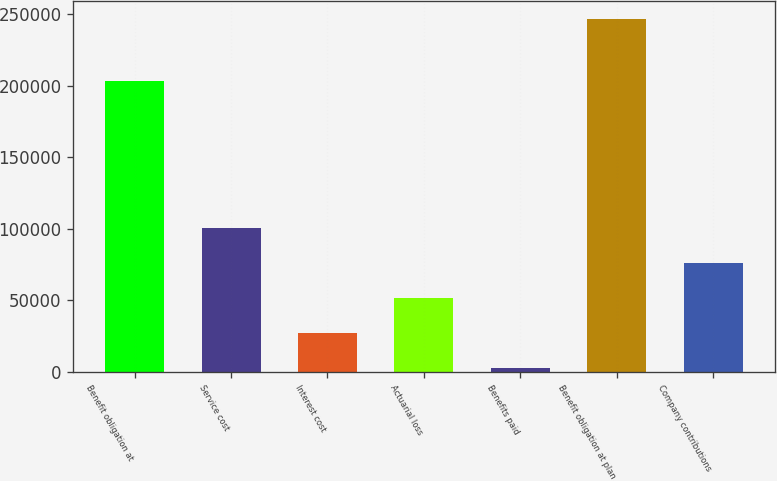Convert chart to OTSL. <chart><loc_0><loc_0><loc_500><loc_500><bar_chart><fcel>Benefit obligation at<fcel>Service cost<fcel>Interest cost<fcel>Actuarial loss<fcel>Benefits paid<fcel>Benefit obligation at plan<fcel>Company contributions<nl><fcel>203292<fcel>100416<fcel>27131.2<fcel>51559.4<fcel>2703<fcel>246985<fcel>75987.6<nl></chart> 